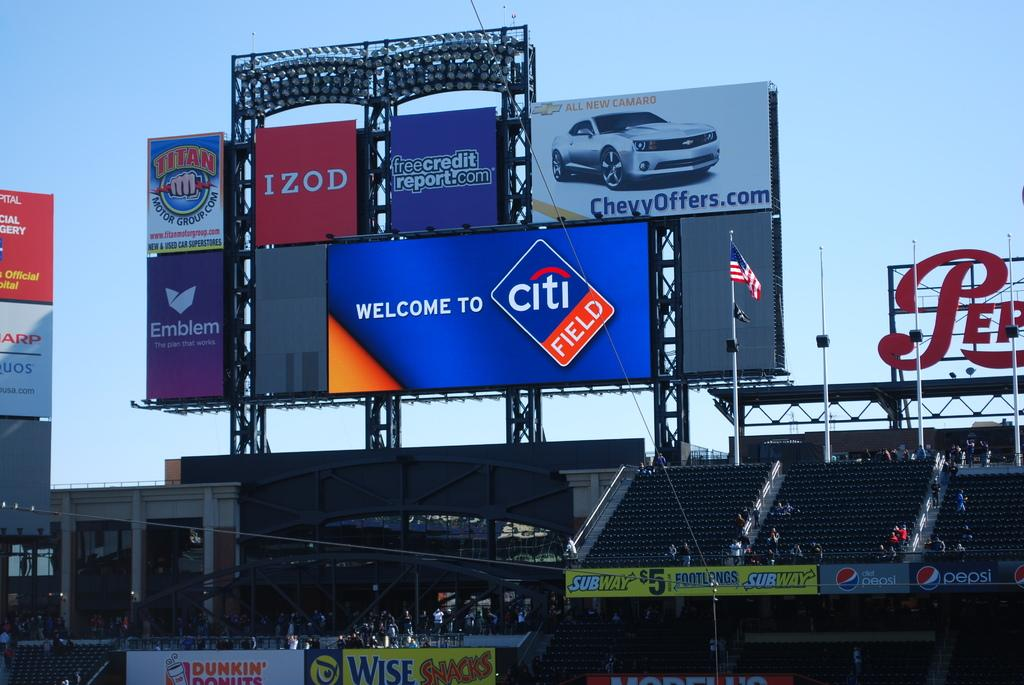<image>
Summarize the visual content of the image. a giant screen displaying welcome to citi field with ads for chevy and izod on top. 